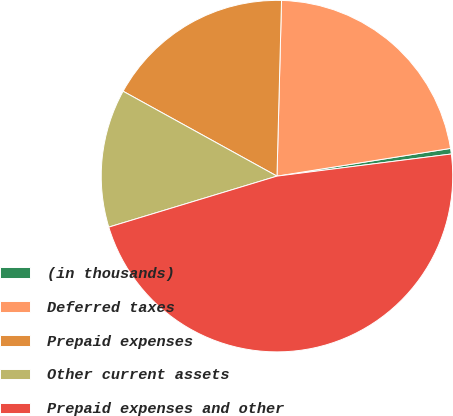Convert chart. <chart><loc_0><loc_0><loc_500><loc_500><pie_chart><fcel>(in thousands)<fcel>Deferred taxes<fcel>Prepaid expenses<fcel>Other current assets<fcel>Prepaid expenses and other<nl><fcel>0.51%<fcel>22.07%<fcel>17.39%<fcel>12.71%<fcel>47.33%<nl></chart> 